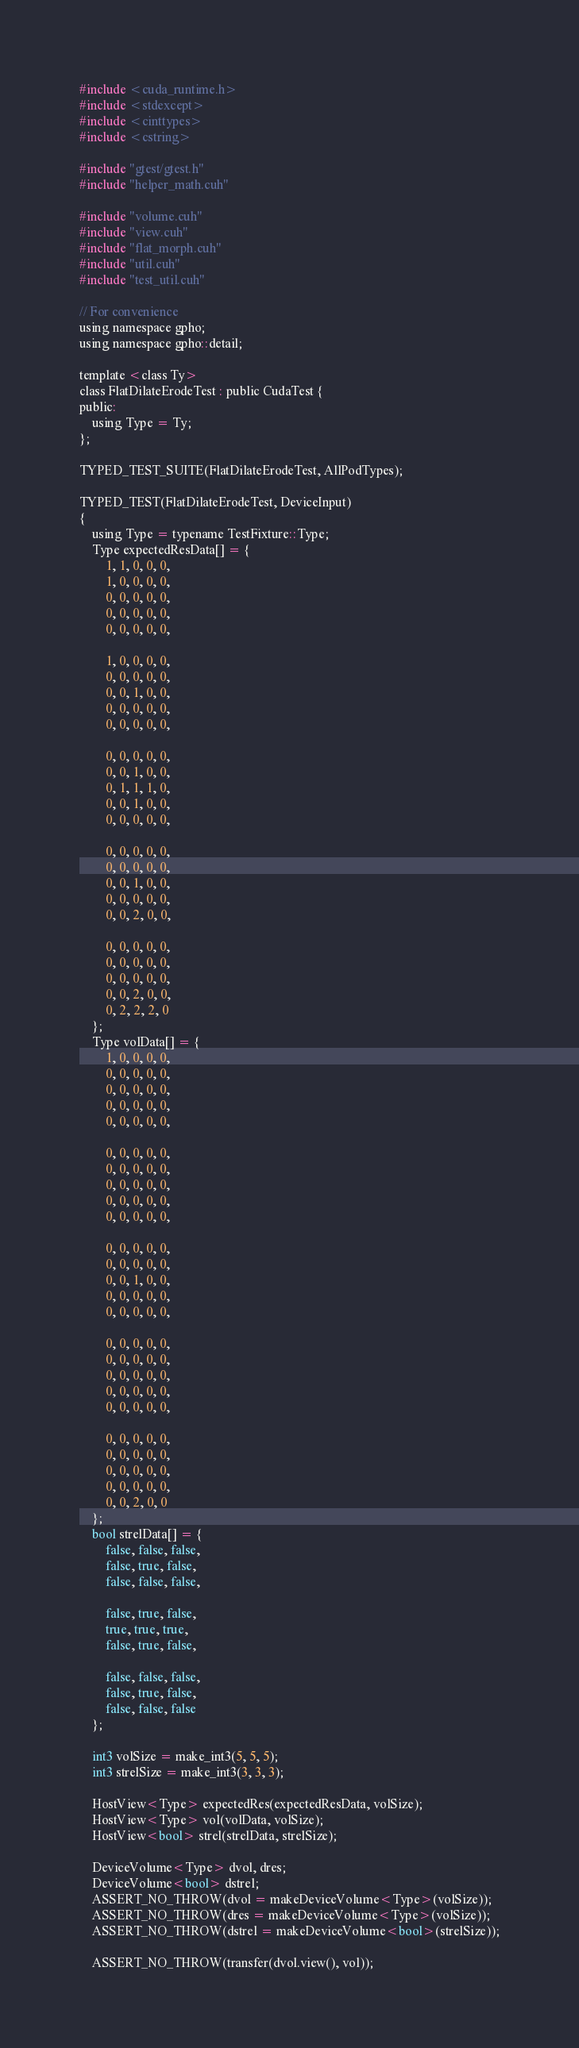Convert code to text. <code><loc_0><loc_0><loc_500><loc_500><_Cuda_>#include <cuda_runtime.h>
#include <stdexcept>
#include <cinttypes>
#include <cstring>

#include "gtest/gtest.h"
#include "helper_math.cuh"

#include "volume.cuh"
#include "view.cuh"
#include "flat_morph.cuh"
#include "util.cuh"
#include "test_util.cuh"

// For convenience
using namespace gpho;
using namespace gpho::detail;

template <class Ty>
class FlatDilateErodeTest : public CudaTest {
public:
    using Type = Ty;
};

TYPED_TEST_SUITE(FlatDilateErodeTest, AllPodTypes);

TYPED_TEST(FlatDilateErodeTest, DeviceInput)
{
    using Type = typename TestFixture::Type;
    Type expectedResData[] = {
        1, 1, 0, 0, 0,
        1, 0, 0, 0, 0,
        0, 0, 0, 0, 0,
        0, 0, 0, 0, 0,
        0, 0, 0, 0, 0,

        1, 0, 0, 0, 0,
        0, 0, 0, 0, 0,
        0, 0, 1, 0, 0,
        0, 0, 0, 0, 0,
        0, 0, 0, 0, 0,

        0, 0, 0, 0, 0,
        0, 0, 1, 0, 0,
        0, 1, 1, 1, 0,
        0, 0, 1, 0, 0,
        0, 0, 0, 0, 0,

        0, 0, 0, 0, 0,
        0, 0, 0, 0, 0,
        0, 0, 1, 0, 0,
        0, 0, 0, 0, 0,
        0, 0, 2, 0, 0,

        0, 0, 0, 0, 0,
        0, 0, 0, 0, 0,
        0, 0, 0, 0, 0,
        0, 0, 2, 0, 0,
        0, 2, 2, 2, 0
    };
    Type volData[] = {
        1, 0, 0, 0, 0,
        0, 0, 0, 0, 0,
        0, 0, 0, 0, 0,
        0, 0, 0, 0, 0,
        0, 0, 0, 0, 0,

        0, 0, 0, 0, 0,
        0, 0, 0, 0, 0,
        0, 0, 0, 0, 0,
        0, 0, 0, 0, 0,
        0, 0, 0, 0, 0,

        0, 0, 0, 0, 0,
        0, 0, 0, 0, 0,
        0, 0, 1, 0, 0,
        0, 0, 0, 0, 0,
        0, 0, 0, 0, 0,

        0, 0, 0, 0, 0,
        0, 0, 0, 0, 0,
        0, 0, 0, 0, 0,
        0, 0, 0, 0, 0,
        0, 0, 0, 0, 0,

        0, 0, 0, 0, 0,
        0, 0, 0, 0, 0,
        0, 0, 0, 0, 0,
        0, 0, 0, 0, 0,
        0, 0, 2, 0, 0
    };
    bool strelData[] = {
        false, false, false,
        false, true, false,
        false, false, false,

        false, true, false,
        true, true, true,
        false, true, false,

        false, false, false,
        false, true, false,
        false, false, false
    };

    int3 volSize = make_int3(5, 5, 5);
    int3 strelSize = make_int3(3, 3, 3);

    HostView<Type> expectedRes(expectedResData, volSize);
    HostView<Type> vol(volData, volSize);
    HostView<bool> strel(strelData, strelSize);

    DeviceVolume<Type> dvol, dres;
    DeviceVolume<bool> dstrel;
    ASSERT_NO_THROW(dvol = makeDeviceVolume<Type>(volSize));
    ASSERT_NO_THROW(dres = makeDeviceVolume<Type>(volSize));
    ASSERT_NO_THROW(dstrel = makeDeviceVolume<bool>(strelSize));

    ASSERT_NO_THROW(transfer(dvol.view(), vol));</code> 